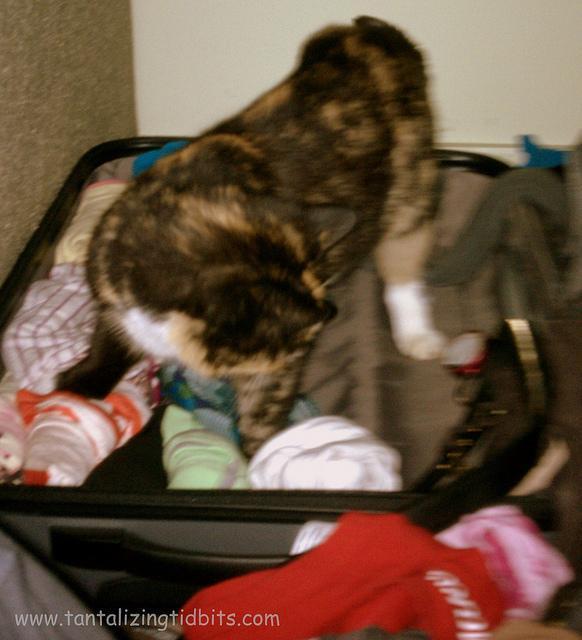How many people are occupying chairs in this picture?
Give a very brief answer. 0. 